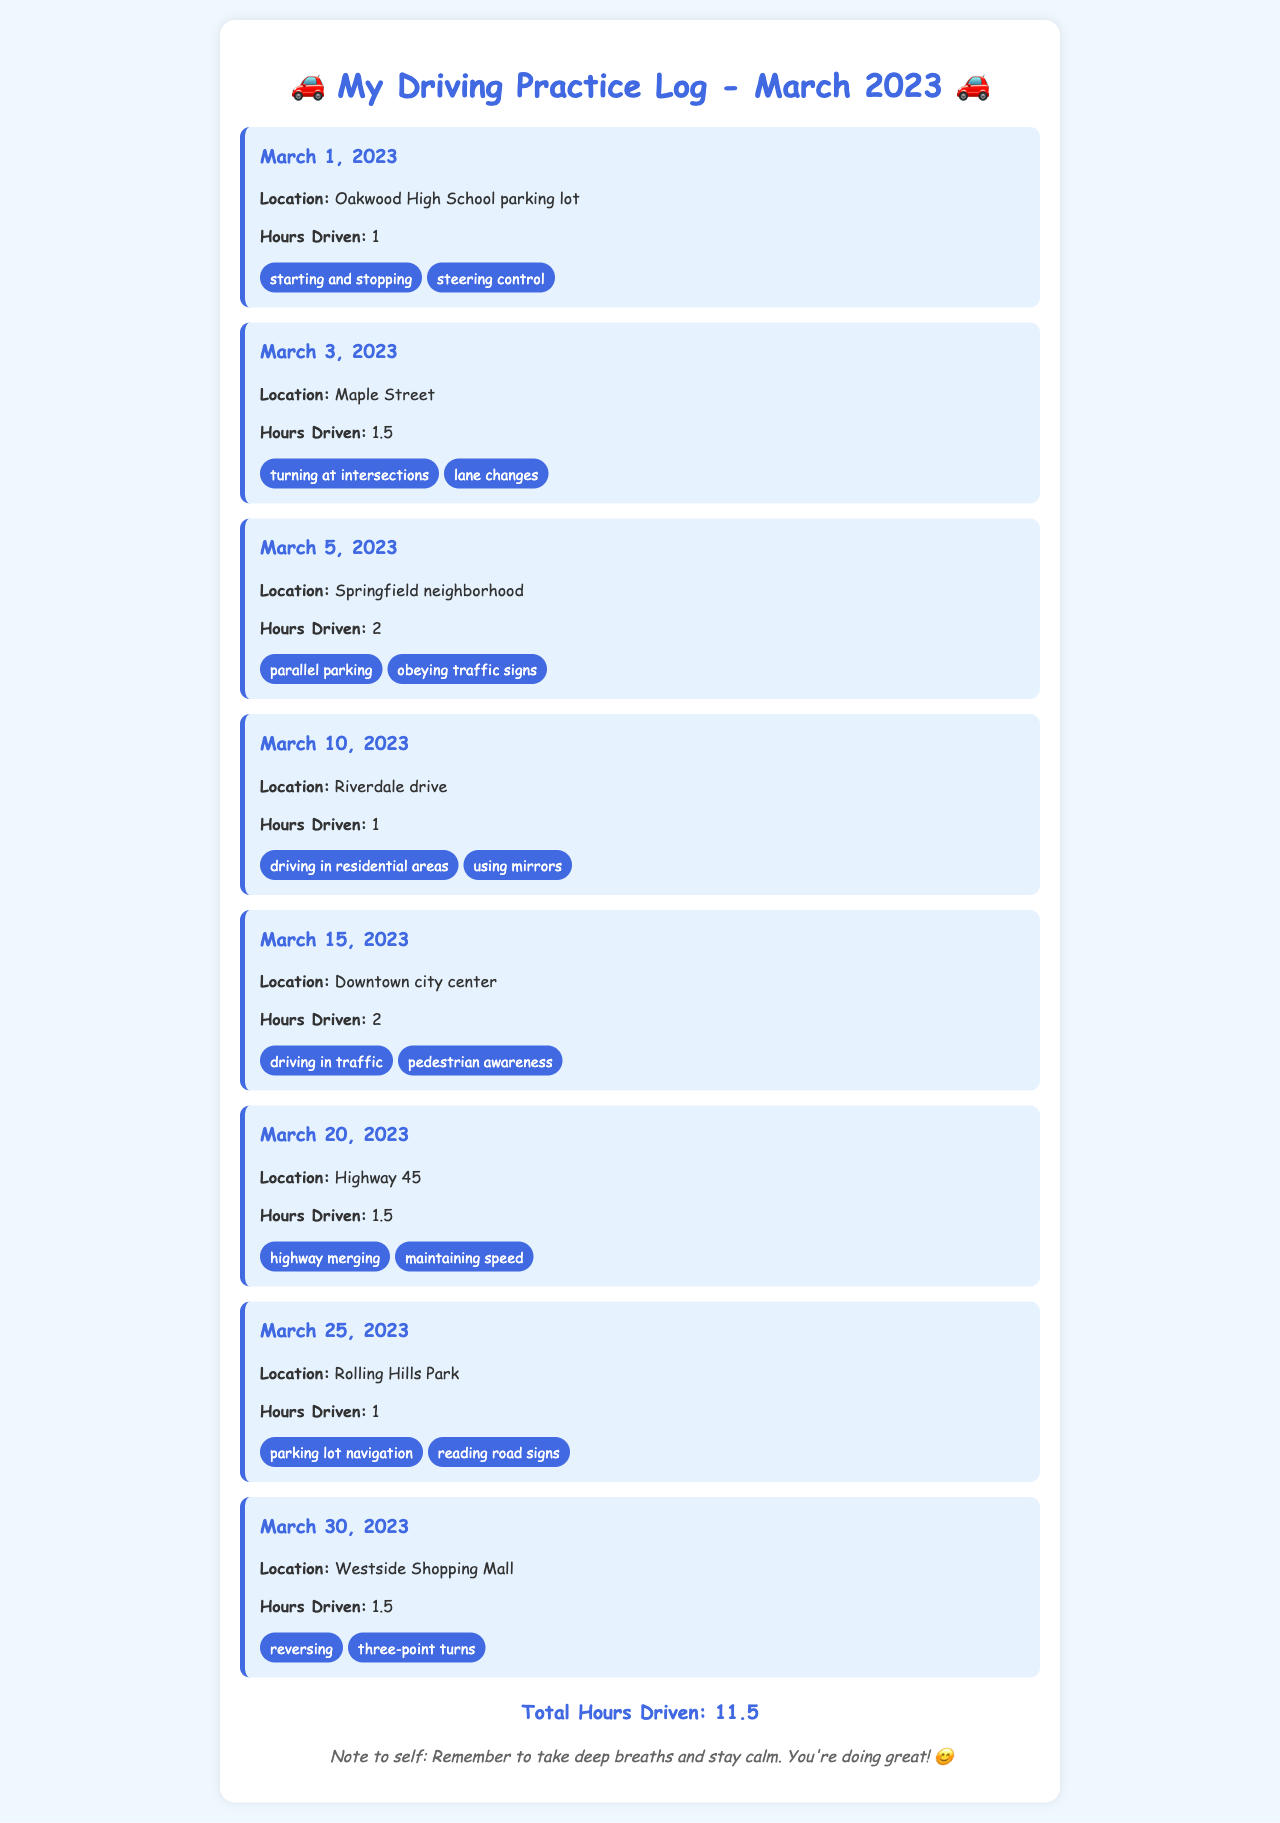What is the total number of hours driven? The total number of hours driven is clearly stated at the bottom of the document.
Answer: 11.5 On what date did the driving session at Oakwood High School take place? The date for the session held at Oakwood High School is mentioned in the entry.
Answer: March 1, 2023 Which skill was practiced during the session on March 15, 2023? The skills practiced are listed in each log entry, including the session for March 15, 2023.
Answer: driving in traffic How many hours were driven on March 3, 2023? The hours driven on March 3, 2023, are specified in the log entry for that date.
Answer: 1.5 What location was used for practicing parking lot navigation? The location for parking lot navigation is mentioned in the entry for March 25, 2023.
Answer: Rolling Hills Park Which two skills were practiced during the session on the highway? The skills practiced on Highway 45 are listed in the corresponding entry.
Answer: highway merging, maintaining speed 